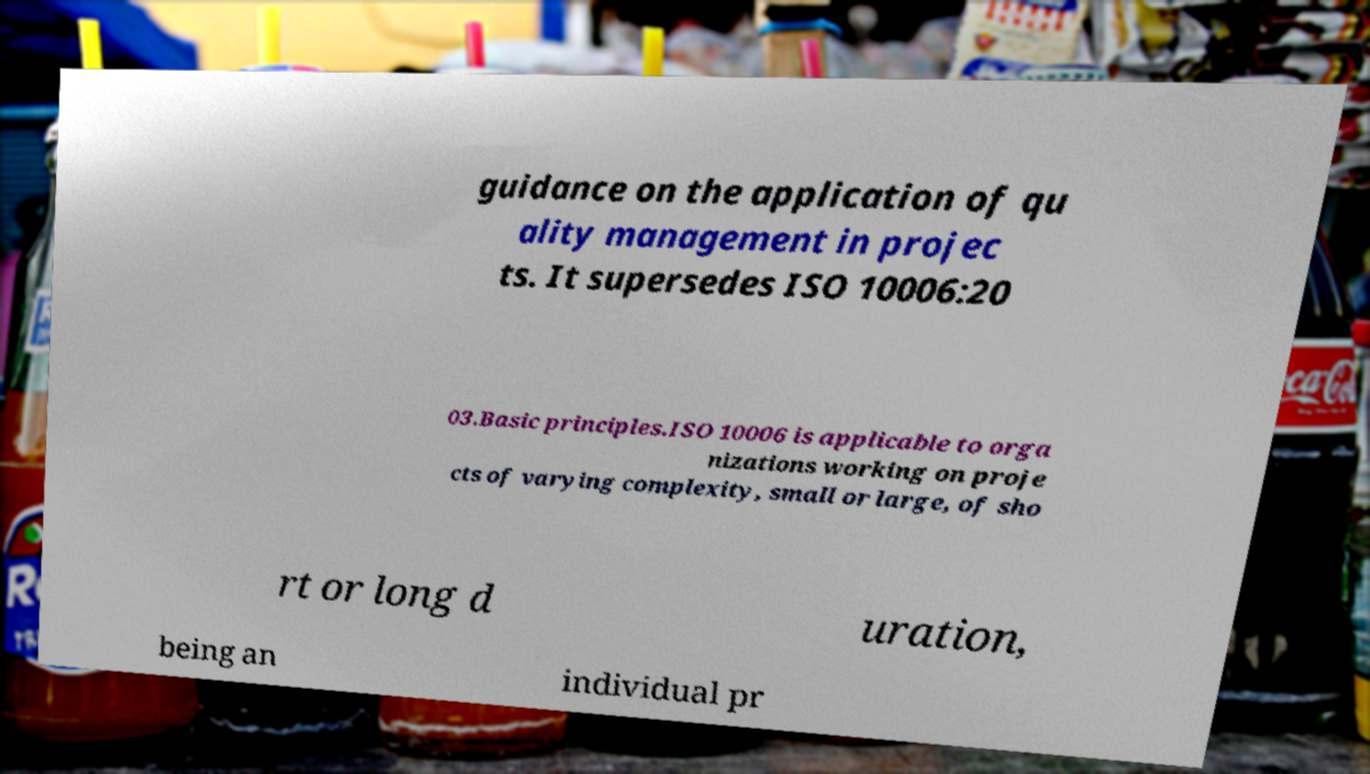I need the written content from this picture converted into text. Can you do that? guidance on the application of qu ality management in projec ts. It supersedes ISO 10006:20 03.Basic principles.ISO 10006 is applicable to orga nizations working on proje cts of varying complexity, small or large, of sho rt or long d uration, being an individual pr 